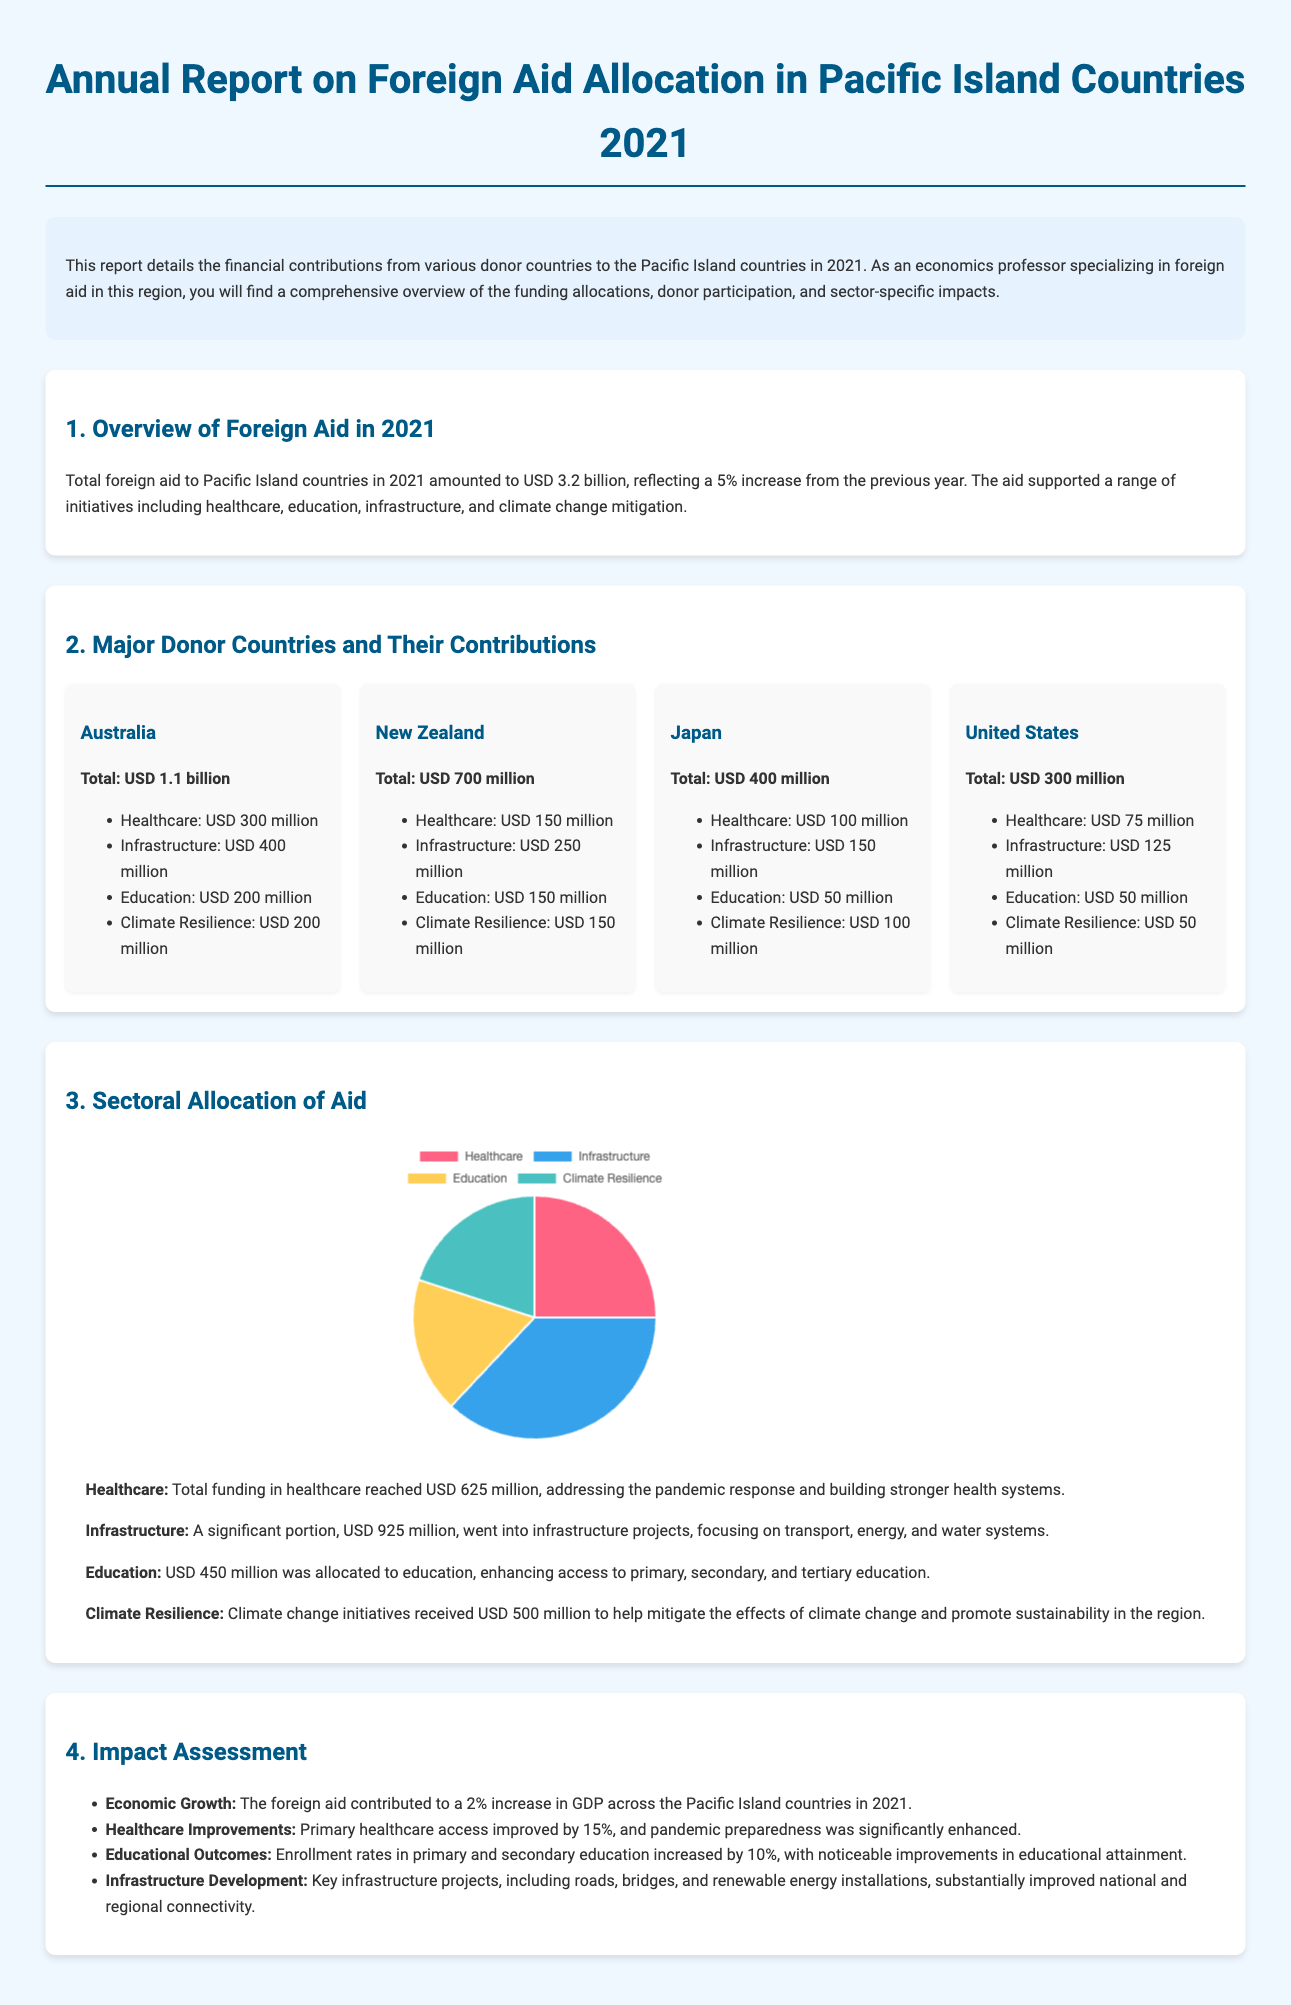What was the total foreign aid to Pacific Island countries in 2021? The total foreign aid amount is stated in the document as USD 3.2 billion.
Answer: USD 3.2 billion How much did Australia contribute to foreign aid? The document specifies the total contribution from Australia as USD 1.1 billion.
Answer: USD 1.1 billion What percentage increase in total foreign aid occurred from the previous year? The report notes a 5% increase from the previous year's aid.
Answer: 5% Which sector received the highest amount of aid? The document lists infrastructure as the sector with the highest funding allocation, totaling USD 925 million.
Answer: Infrastructure What impact did foreign aid have on GDP growth in Pacific Island countries? The report indicates that foreign aid contributed to a 2% increase in GDP across the Pacific Island countries.
Answer: 2% How much funding did the United States allocate for climate resilience? The document states that the United States allocated USD 50 million for climate resilience.
Answer: USD 50 million Which donor country contributed the least to healthcare funding? The document shows that Japan contributed USD 100 million, which is the lowest among the listed contributions for healthcare.
Answer: Japan What was the total funding in the education sector? The total funding for education is specified in the document as USD 450 million.
Answer: USD 450 million What type of document is this? This document is described as an annual report detailing foreign aid allocation in Pacific Island countries.
Answer: Annual report 